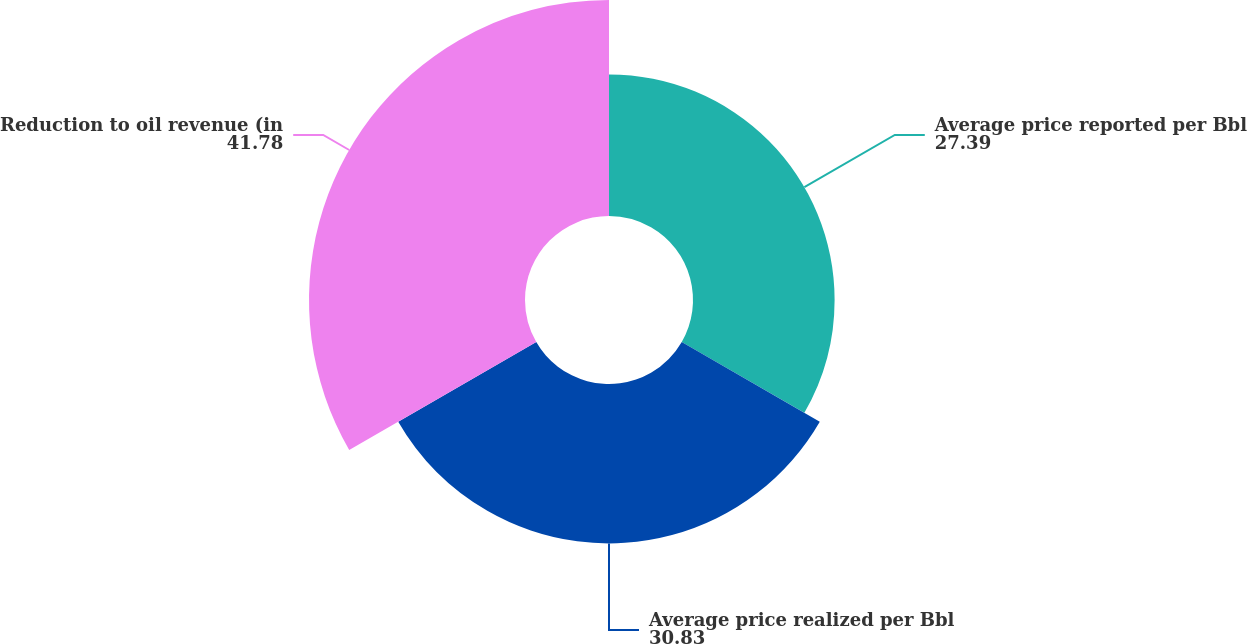Convert chart to OTSL. <chart><loc_0><loc_0><loc_500><loc_500><pie_chart><fcel>Average price reported per Bbl<fcel>Average price realized per Bbl<fcel>Reduction to oil revenue (in<nl><fcel>27.39%<fcel>30.83%<fcel>41.78%<nl></chart> 